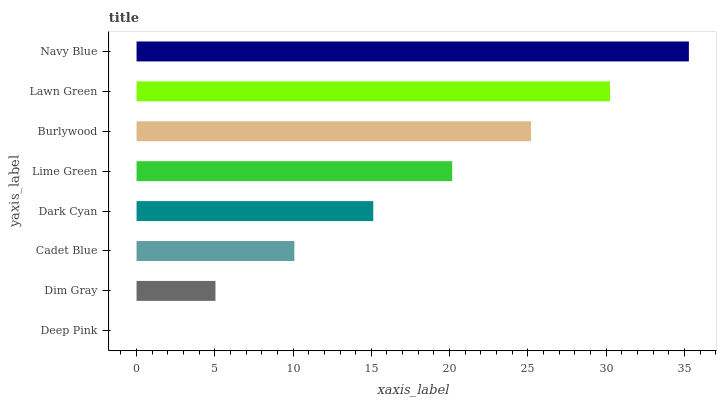Is Deep Pink the minimum?
Answer yes or no. Yes. Is Navy Blue the maximum?
Answer yes or no. Yes. Is Dim Gray the minimum?
Answer yes or no. No. Is Dim Gray the maximum?
Answer yes or no. No. Is Dim Gray greater than Deep Pink?
Answer yes or no. Yes. Is Deep Pink less than Dim Gray?
Answer yes or no. Yes. Is Deep Pink greater than Dim Gray?
Answer yes or no. No. Is Dim Gray less than Deep Pink?
Answer yes or no. No. Is Lime Green the high median?
Answer yes or no. Yes. Is Dark Cyan the low median?
Answer yes or no. Yes. Is Cadet Blue the high median?
Answer yes or no. No. Is Burlywood the low median?
Answer yes or no. No. 